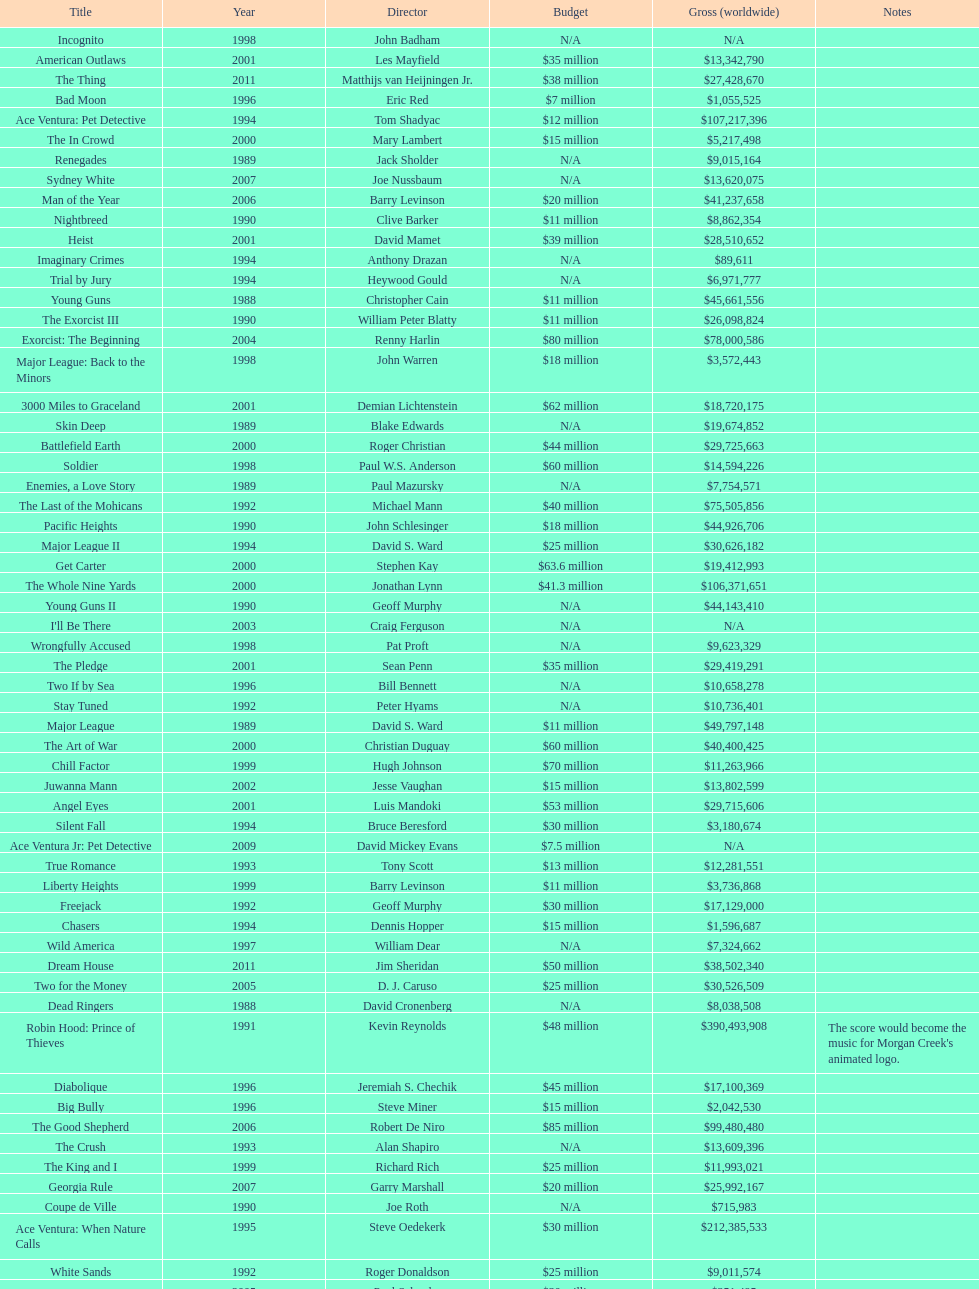How many films were there in 1990? 5. 